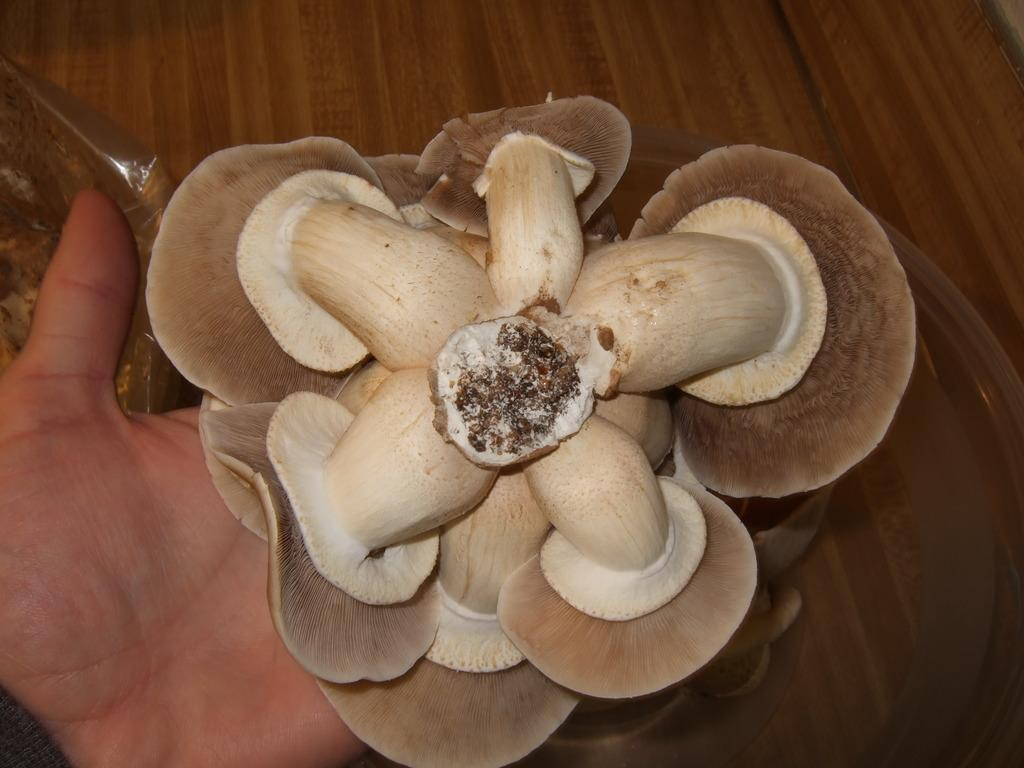What is the person in the image wearing? The person in the image is wearing a black dress. What is the person holding in the image? The person is holding mushrooms. Can you describe the setting where the person is located? There is a table near a wall in the image. What type of ghost can be seen interacting with the mushrooms in the image? There is no ghost present in the image; it features a person holding mushrooms. What unit of measurement is used to determine the size of the mushrooms in the image? The provided facts do not mention any unit of measurement for the mushrooms, so it cannot be determined from the image. 